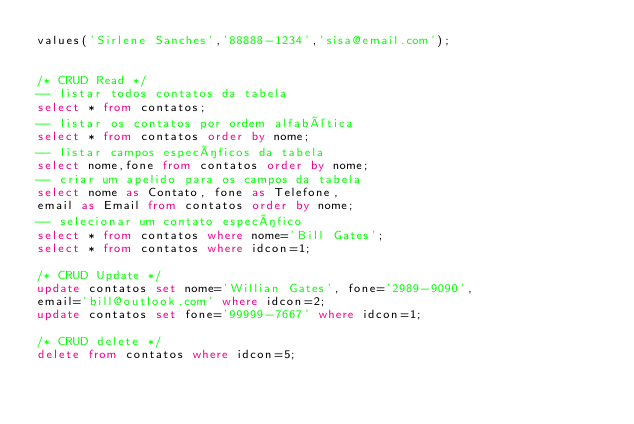Convert code to text. <code><loc_0><loc_0><loc_500><loc_500><_SQL_>values('Sirlene Sanches','88888-1234','sisa@email.com');


/* CRUD Read */
-- listar todos contatos da tabela
select * from contatos;
-- listar os contatos por ordem alfabética
select * from contatos order by nome; 
-- listar campos específicos da tabela
select nome,fone from contatos order by nome;
-- criar um apelido para os campos da tabela
select nome as Contato, fone as Telefone,
email as Email from contatos order by nome;
-- selecionar um contato específico
select * from contatos where nome='Bill Gates';
select * from contatos where idcon=1;

/* CRUD Update */
update contatos set nome='Willian Gates', fone='2989-9090',
email='bill@outlook.com' where idcon=2;
update contatos set fone='99999-7667' where idcon=1;

/* CRUD delete */
delete from contatos where idcon=5;
</code> 